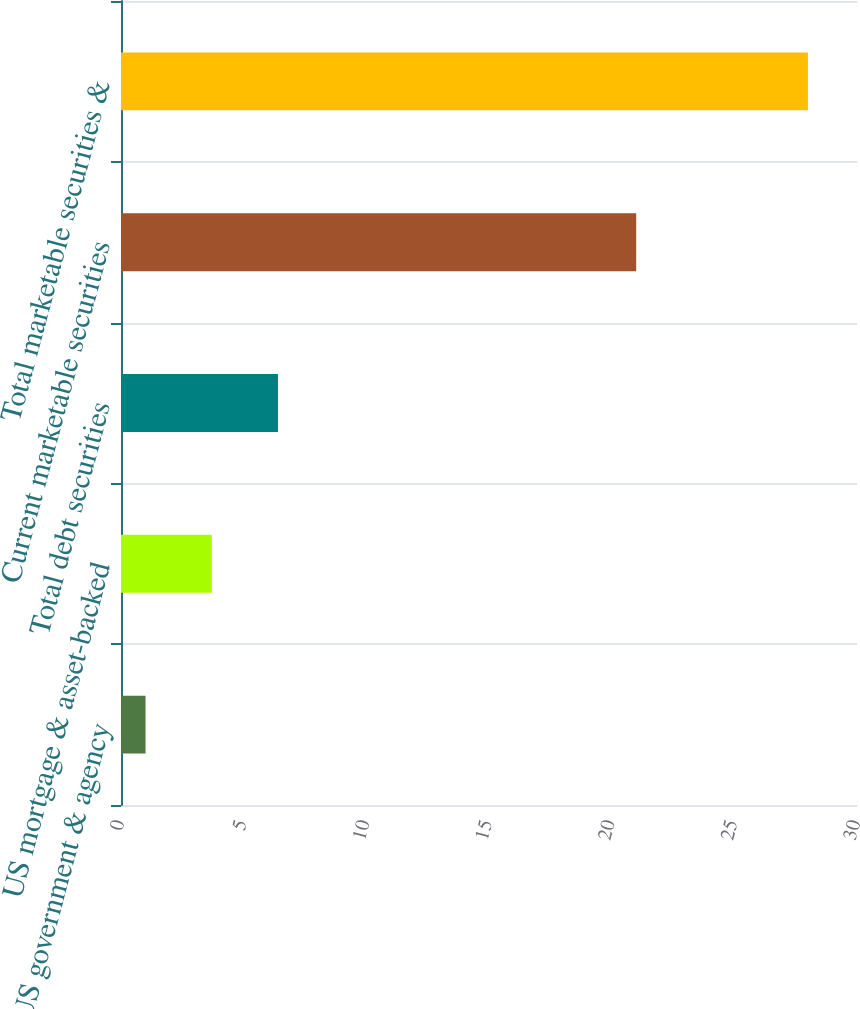<chart> <loc_0><loc_0><loc_500><loc_500><bar_chart><fcel>US government & agency<fcel>US mortgage & asset-backed<fcel>Total debt securities<fcel>Current marketable securities<fcel>Total marketable securities &<nl><fcel>1<fcel>3.7<fcel>6.4<fcel>21<fcel>28<nl></chart> 